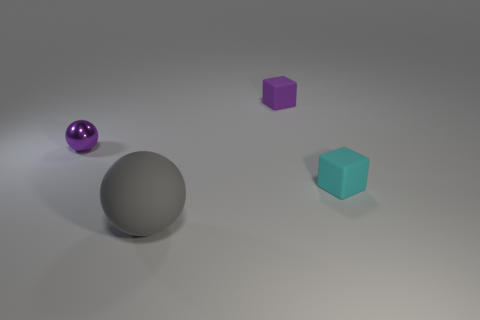Is the number of big objects that are behind the purple shiny object less than the number of tiny brown metallic blocks?
Make the answer very short. No. Do the matte cube that is on the left side of the cyan block and the small cyan matte cube have the same size?
Your answer should be very brief. Yes. How many things are on the left side of the cyan matte object and in front of the small purple block?
Offer a very short reply. 2. What is the size of the sphere that is in front of the tiny purple thing in front of the purple matte thing?
Provide a succinct answer. Large. Is the number of tiny purple matte objects that are on the left side of the tiny purple block less than the number of spheres that are on the right side of the shiny ball?
Ensure brevity in your answer.  Yes. There is a tiny cube that is behind the metal thing; is it the same color as the ball behind the big sphere?
Ensure brevity in your answer.  Yes. What is the material of the thing that is both in front of the metal sphere and on the right side of the gray ball?
Provide a succinct answer. Rubber. Are there any gray spheres?
Make the answer very short. Yes. There is a small cyan object that is made of the same material as the tiny purple cube; what shape is it?
Give a very brief answer. Cube. Does the tiny cyan thing have the same shape as the matte thing that is behind the cyan thing?
Your response must be concise. Yes. 